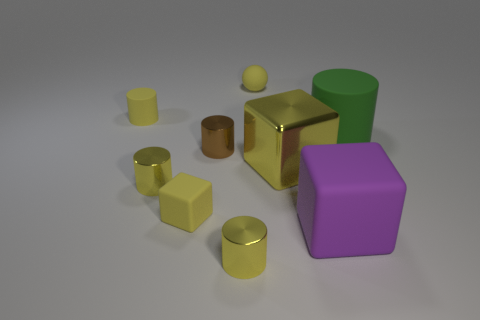Subtract all brown blocks. How many yellow cylinders are left? 3 Subtract all tiny yellow rubber cylinders. How many cylinders are left? 4 Subtract all brown cylinders. How many cylinders are left? 4 Subtract all purple cylinders. Subtract all blue spheres. How many cylinders are left? 5 Add 1 big red shiny cylinders. How many objects exist? 10 Subtract all spheres. How many objects are left? 8 Add 3 small rubber objects. How many small rubber objects are left? 6 Add 4 big things. How many big things exist? 7 Subtract 0 red spheres. How many objects are left? 9 Subtract all matte objects. Subtract all brown metal cylinders. How many objects are left? 3 